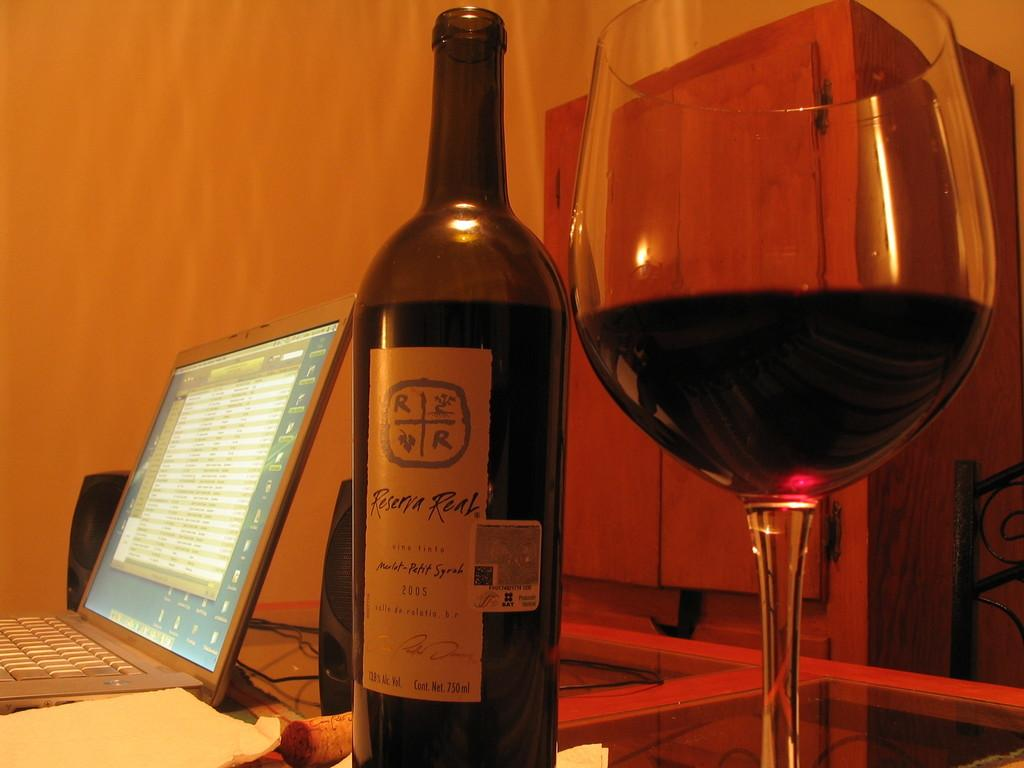<image>
Summarize the visual content of the image. the word reserva that is on a bottle 